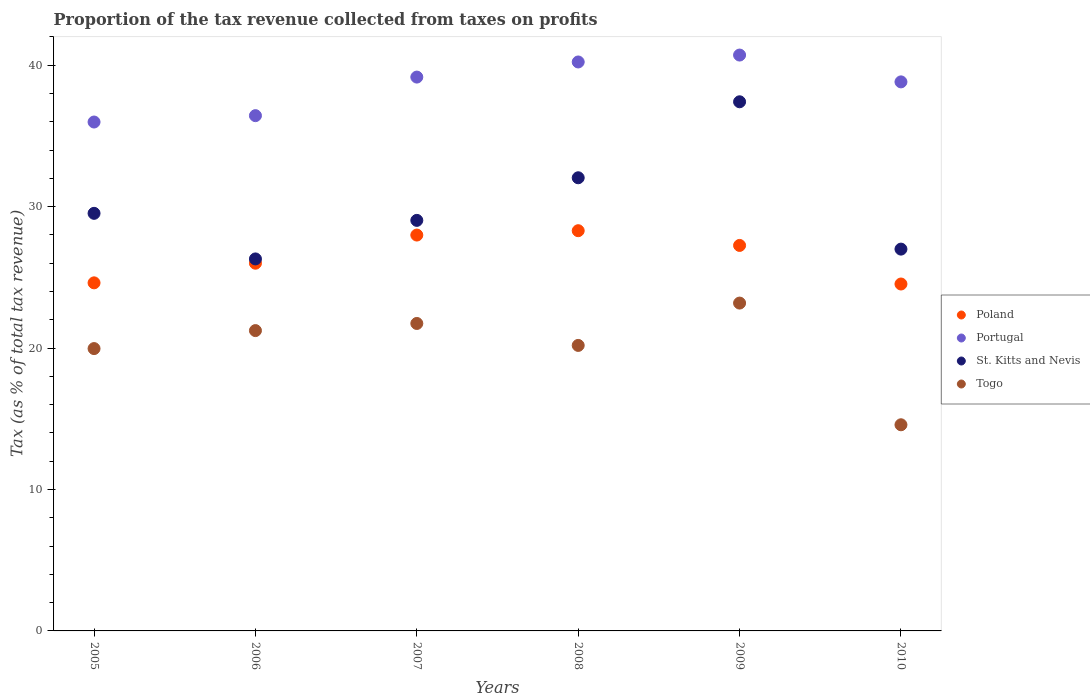What is the proportion of the tax revenue collected in Poland in 2007?
Your answer should be very brief. 27.99. Across all years, what is the maximum proportion of the tax revenue collected in Togo?
Offer a terse response. 23.18. Across all years, what is the minimum proportion of the tax revenue collected in Poland?
Offer a very short reply. 24.53. In which year was the proportion of the tax revenue collected in St. Kitts and Nevis minimum?
Provide a succinct answer. 2006. What is the total proportion of the tax revenue collected in Togo in the graph?
Offer a terse response. 120.88. What is the difference between the proportion of the tax revenue collected in St. Kitts and Nevis in 2005 and that in 2009?
Your answer should be compact. -7.89. What is the difference between the proportion of the tax revenue collected in Portugal in 2009 and the proportion of the tax revenue collected in Poland in 2008?
Your answer should be very brief. 12.42. What is the average proportion of the tax revenue collected in St. Kitts and Nevis per year?
Provide a succinct answer. 30.22. In the year 2009, what is the difference between the proportion of the tax revenue collected in Portugal and proportion of the tax revenue collected in Togo?
Offer a very short reply. 17.54. What is the ratio of the proportion of the tax revenue collected in Poland in 2005 to that in 2009?
Ensure brevity in your answer.  0.9. Is the difference between the proportion of the tax revenue collected in Portugal in 2007 and 2009 greater than the difference between the proportion of the tax revenue collected in Togo in 2007 and 2009?
Your answer should be compact. No. What is the difference between the highest and the second highest proportion of the tax revenue collected in St. Kitts and Nevis?
Offer a terse response. 5.37. What is the difference between the highest and the lowest proportion of the tax revenue collected in Portugal?
Your answer should be compact. 4.73. Is it the case that in every year, the sum of the proportion of the tax revenue collected in Poland and proportion of the tax revenue collected in St. Kitts and Nevis  is greater than the proportion of the tax revenue collected in Portugal?
Your answer should be compact. Yes. Does the proportion of the tax revenue collected in Poland monotonically increase over the years?
Give a very brief answer. No. How many dotlines are there?
Offer a very short reply. 4. How many years are there in the graph?
Your answer should be compact. 6. Are the values on the major ticks of Y-axis written in scientific E-notation?
Your response must be concise. No. Does the graph contain any zero values?
Keep it short and to the point. No. What is the title of the graph?
Offer a very short reply. Proportion of the tax revenue collected from taxes on profits. Does "Congo (Democratic)" appear as one of the legend labels in the graph?
Give a very brief answer. No. What is the label or title of the Y-axis?
Ensure brevity in your answer.  Tax (as % of total tax revenue). What is the Tax (as % of total tax revenue) in Poland in 2005?
Make the answer very short. 24.61. What is the Tax (as % of total tax revenue) in Portugal in 2005?
Your answer should be very brief. 35.98. What is the Tax (as % of total tax revenue) of St. Kitts and Nevis in 2005?
Your answer should be compact. 29.53. What is the Tax (as % of total tax revenue) of Togo in 2005?
Make the answer very short. 19.96. What is the Tax (as % of total tax revenue) of Poland in 2006?
Give a very brief answer. 26. What is the Tax (as % of total tax revenue) of Portugal in 2006?
Keep it short and to the point. 36.43. What is the Tax (as % of total tax revenue) in St. Kitts and Nevis in 2006?
Your answer should be very brief. 26.3. What is the Tax (as % of total tax revenue) of Togo in 2006?
Your answer should be compact. 21.24. What is the Tax (as % of total tax revenue) in Poland in 2007?
Your answer should be compact. 27.99. What is the Tax (as % of total tax revenue) in Portugal in 2007?
Give a very brief answer. 39.16. What is the Tax (as % of total tax revenue) of St. Kitts and Nevis in 2007?
Make the answer very short. 29.03. What is the Tax (as % of total tax revenue) of Togo in 2007?
Keep it short and to the point. 21.74. What is the Tax (as % of total tax revenue) in Poland in 2008?
Your answer should be compact. 28.3. What is the Tax (as % of total tax revenue) in Portugal in 2008?
Your answer should be very brief. 40.23. What is the Tax (as % of total tax revenue) in St. Kitts and Nevis in 2008?
Ensure brevity in your answer.  32.04. What is the Tax (as % of total tax revenue) of Togo in 2008?
Ensure brevity in your answer.  20.19. What is the Tax (as % of total tax revenue) of Poland in 2009?
Your response must be concise. 27.26. What is the Tax (as % of total tax revenue) of Portugal in 2009?
Offer a very short reply. 40.72. What is the Tax (as % of total tax revenue) of St. Kitts and Nevis in 2009?
Ensure brevity in your answer.  37.41. What is the Tax (as % of total tax revenue) in Togo in 2009?
Offer a terse response. 23.18. What is the Tax (as % of total tax revenue) of Poland in 2010?
Offer a terse response. 24.53. What is the Tax (as % of total tax revenue) in Portugal in 2010?
Give a very brief answer. 38.82. What is the Tax (as % of total tax revenue) in St. Kitts and Nevis in 2010?
Your answer should be compact. 27. What is the Tax (as % of total tax revenue) of Togo in 2010?
Provide a short and direct response. 14.58. Across all years, what is the maximum Tax (as % of total tax revenue) in Poland?
Offer a terse response. 28.3. Across all years, what is the maximum Tax (as % of total tax revenue) in Portugal?
Keep it short and to the point. 40.72. Across all years, what is the maximum Tax (as % of total tax revenue) in St. Kitts and Nevis?
Your response must be concise. 37.41. Across all years, what is the maximum Tax (as % of total tax revenue) of Togo?
Your response must be concise. 23.18. Across all years, what is the minimum Tax (as % of total tax revenue) of Poland?
Your response must be concise. 24.53. Across all years, what is the minimum Tax (as % of total tax revenue) in Portugal?
Ensure brevity in your answer.  35.98. Across all years, what is the minimum Tax (as % of total tax revenue) in St. Kitts and Nevis?
Give a very brief answer. 26.3. Across all years, what is the minimum Tax (as % of total tax revenue) of Togo?
Your answer should be very brief. 14.58. What is the total Tax (as % of total tax revenue) in Poland in the graph?
Give a very brief answer. 158.69. What is the total Tax (as % of total tax revenue) of Portugal in the graph?
Your response must be concise. 231.35. What is the total Tax (as % of total tax revenue) in St. Kitts and Nevis in the graph?
Ensure brevity in your answer.  181.31. What is the total Tax (as % of total tax revenue) of Togo in the graph?
Provide a succinct answer. 120.88. What is the difference between the Tax (as % of total tax revenue) of Poland in 2005 and that in 2006?
Ensure brevity in your answer.  -1.39. What is the difference between the Tax (as % of total tax revenue) in Portugal in 2005 and that in 2006?
Provide a short and direct response. -0.45. What is the difference between the Tax (as % of total tax revenue) in St. Kitts and Nevis in 2005 and that in 2006?
Ensure brevity in your answer.  3.22. What is the difference between the Tax (as % of total tax revenue) in Togo in 2005 and that in 2006?
Provide a succinct answer. -1.27. What is the difference between the Tax (as % of total tax revenue) in Poland in 2005 and that in 2007?
Offer a terse response. -3.38. What is the difference between the Tax (as % of total tax revenue) of Portugal in 2005 and that in 2007?
Your response must be concise. -3.18. What is the difference between the Tax (as % of total tax revenue) of St. Kitts and Nevis in 2005 and that in 2007?
Ensure brevity in your answer.  0.5. What is the difference between the Tax (as % of total tax revenue) in Togo in 2005 and that in 2007?
Your answer should be compact. -1.78. What is the difference between the Tax (as % of total tax revenue) in Poland in 2005 and that in 2008?
Your answer should be compact. -3.69. What is the difference between the Tax (as % of total tax revenue) of Portugal in 2005 and that in 2008?
Make the answer very short. -4.25. What is the difference between the Tax (as % of total tax revenue) in St. Kitts and Nevis in 2005 and that in 2008?
Offer a terse response. -2.52. What is the difference between the Tax (as % of total tax revenue) in Togo in 2005 and that in 2008?
Ensure brevity in your answer.  -0.22. What is the difference between the Tax (as % of total tax revenue) in Poland in 2005 and that in 2009?
Keep it short and to the point. -2.65. What is the difference between the Tax (as % of total tax revenue) of Portugal in 2005 and that in 2009?
Your response must be concise. -4.73. What is the difference between the Tax (as % of total tax revenue) in St. Kitts and Nevis in 2005 and that in 2009?
Provide a short and direct response. -7.89. What is the difference between the Tax (as % of total tax revenue) of Togo in 2005 and that in 2009?
Offer a terse response. -3.22. What is the difference between the Tax (as % of total tax revenue) in Poland in 2005 and that in 2010?
Make the answer very short. 0.08. What is the difference between the Tax (as % of total tax revenue) in Portugal in 2005 and that in 2010?
Give a very brief answer. -2.84. What is the difference between the Tax (as % of total tax revenue) of St. Kitts and Nevis in 2005 and that in 2010?
Your answer should be compact. 2.53. What is the difference between the Tax (as % of total tax revenue) of Togo in 2005 and that in 2010?
Ensure brevity in your answer.  5.39. What is the difference between the Tax (as % of total tax revenue) in Poland in 2006 and that in 2007?
Your answer should be compact. -1.99. What is the difference between the Tax (as % of total tax revenue) in Portugal in 2006 and that in 2007?
Provide a succinct answer. -2.73. What is the difference between the Tax (as % of total tax revenue) in St. Kitts and Nevis in 2006 and that in 2007?
Make the answer very short. -2.73. What is the difference between the Tax (as % of total tax revenue) in Togo in 2006 and that in 2007?
Your answer should be very brief. -0.5. What is the difference between the Tax (as % of total tax revenue) of Poland in 2006 and that in 2008?
Your answer should be very brief. -2.3. What is the difference between the Tax (as % of total tax revenue) of Portugal in 2006 and that in 2008?
Offer a terse response. -3.8. What is the difference between the Tax (as % of total tax revenue) in St. Kitts and Nevis in 2006 and that in 2008?
Provide a short and direct response. -5.74. What is the difference between the Tax (as % of total tax revenue) in Togo in 2006 and that in 2008?
Ensure brevity in your answer.  1.05. What is the difference between the Tax (as % of total tax revenue) of Poland in 2006 and that in 2009?
Your response must be concise. -1.26. What is the difference between the Tax (as % of total tax revenue) of Portugal in 2006 and that in 2009?
Offer a terse response. -4.28. What is the difference between the Tax (as % of total tax revenue) in St. Kitts and Nevis in 2006 and that in 2009?
Keep it short and to the point. -11.11. What is the difference between the Tax (as % of total tax revenue) of Togo in 2006 and that in 2009?
Offer a terse response. -1.95. What is the difference between the Tax (as % of total tax revenue) in Poland in 2006 and that in 2010?
Offer a terse response. 1.47. What is the difference between the Tax (as % of total tax revenue) of Portugal in 2006 and that in 2010?
Provide a short and direct response. -2.39. What is the difference between the Tax (as % of total tax revenue) in St. Kitts and Nevis in 2006 and that in 2010?
Provide a short and direct response. -0.69. What is the difference between the Tax (as % of total tax revenue) of Togo in 2006 and that in 2010?
Offer a terse response. 6.66. What is the difference between the Tax (as % of total tax revenue) of Poland in 2007 and that in 2008?
Your answer should be compact. -0.31. What is the difference between the Tax (as % of total tax revenue) of Portugal in 2007 and that in 2008?
Ensure brevity in your answer.  -1.07. What is the difference between the Tax (as % of total tax revenue) in St. Kitts and Nevis in 2007 and that in 2008?
Give a very brief answer. -3.01. What is the difference between the Tax (as % of total tax revenue) in Togo in 2007 and that in 2008?
Keep it short and to the point. 1.55. What is the difference between the Tax (as % of total tax revenue) of Poland in 2007 and that in 2009?
Provide a short and direct response. 0.73. What is the difference between the Tax (as % of total tax revenue) in Portugal in 2007 and that in 2009?
Make the answer very short. -1.56. What is the difference between the Tax (as % of total tax revenue) of St. Kitts and Nevis in 2007 and that in 2009?
Your answer should be compact. -8.39. What is the difference between the Tax (as % of total tax revenue) in Togo in 2007 and that in 2009?
Your response must be concise. -1.44. What is the difference between the Tax (as % of total tax revenue) in Poland in 2007 and that in 2010?
Keep it short and to the point. 3.46. What is the difference between the Tax (as % of total tax revenue) in Portugal in 2007 and that in 2010?
Make the answer very short. 0.34. What is the difference between the Tax (as % of total tax revenue) in St. Kitts and Nevis in 2007 and that in 2010?
Your answer should be very brief. 2.03. What is the difference between the Tax (as % of total tax revenue) in Togo in 2007 and that in 2010?
Give a very brief answer. 7.16. What is the difference between the Tax (as % of total tax revenue) of Poland in 2008 and that in 2009?
Your answer should be very brief. 1.04. What is the difference between the Tax (as % of total tax revenue) in Portugal in 2008 and that in 2009?
Give a very brief answer. -0.49. What is the difference between the Tax (as % of total tax revenue) in St. Kitts and Nevis in 2008 and that in 2009?
Make the answer very short. -5.37. What is the difference between the Tax (as % of total tax revenue) of Togo in 2008 and that in 2009?
Provide a short and direct response. -2.99. What is the difference between the Tax (as % of total tax revenue) of Poland in 2008 and that in 2010?
Make the answer very short. 3.77. What is the difference between the Tax (as % of total tax revenue) of Portugal in 2008 and that in 2010?
Offer a terse response. 1.41. What is the difference between the Tax (as % of total tax revenue) of St. Kitts and Nevis in 2008 and that in 2010?
Your answer should be compact. 5.04. What is the difference between the Tax (as % of total tax revenue) in Togo in 2008 and that in 2010?
Keep it short and to the point. 5.61. What is the difference between the Tax (as % of total tax revenue) of Poland in 2009 and that in 2010?
Make the answer very short. 2.73. What is the difference between the Tax (as % of total tax revenue) of Portugal in 2009 and that in 2010?
Provide a succinct answer. 1.9. What is the difference between the Tax (as % of total tax revenue) of St. Kitts and Nevis in 2009 and that in 2010?
Your answer should be compact. 10.42. What is the difference between the Tax (as % of total tax revenue) in Togo in 2009 and that in 2010?
Offer a terse response. 8.61. What is the difference between the Tax (as % of total tax revenue) of Poland in 2005 and the Tax (as % of total tax revenue) of Portugal in 2006?
Make the answer very short. -11.82. What is the difference between the Tax (as % of total tax revenue) in Poland in 2005 and the Tax (as % of total tax revenue) in St. Kitts and Nevis in 2006?
Provide a short and direct response. -1.69. What is the difference between the Tax (as % of total tax revenue) in Poland in 2005 and the Tax (as % of total tax revenue) in Togo in 2006?
Keep it short and to the point. 3.38. What is the difference between the Tax (as % of total tax revenue) of Portugal in 2005 and the Tax (as % of total tax revenue) of St. Kitts and Nevis in 2006?
Offer a very short reply. 9.68. What is the difference between the Tax (as % of total tax revenue) of Portugal in 2005 and the Tax (as % of total tax revenue) of Togo in 2006?
Your answer should be very brief. 14.75. What is the difference between the Tax (as % of total tax revenue) in St. Kitts and Nevis in 2005 and the Tax (as % of total tax revenue) in Togo in 2006?
Keep it short and to the point. 8.29. What is the difference between the Tax (as % of total tax revenue) of Poland in 2005 and the Tax (as % of total tax revenue) of Portugal in 2007?
Offer a terse response. -14.55. What is the difference between the Tax (as % of total tax revenue) in Poland in 2005 and the Tax (as % of total tax revenue) in St. Kitts and Nevis in 2007?
Offer a terse response. -4.42. What is the difference between the Tax (as % of total tax revenue) of Poland in 2005 and the Tax (as % of total tax revenue) of Togo in 2007?
Offer a terse response. 2.87. What is the difference between the Tax (as % of total tax revenue) of Portugal in 2005 and the Tax (as % of total tax revenue) of St. Kitts and Nevis in 2007?
Keep it short and to the point. 6.95. What is the difference between the Tax (as % of total tax revenue) of Portugal in 2005 and the Tax (as % of total tax revenue) of Togo in 2007?
Offer a terse response. 14.24. What is the difference between the Tax (as % of total tax revenue) in St. Kitts and Nevis in 2005 and the Tax (as % of total tax revenue) in Togo in 2007?
Offer a very short reply. 7.79. What is the difference between the Tax (as % of total tax revenue) in Poland in 2005 and the Tax (as % of total tax revenue) in Portugal in 2008?
Keep it short and to the point. -15.62. What is the difference between the Tax (as % of total tax revenue) in Poland in 2005 and the Tax (as % of total tax revenue) in St. Kitts and Nevis in 2008?
Your answer should be compact. -7.43. What is the difference between the Tax (as % of total tax revenue) of Poland in 2005 and the Tax (as % of total tax revenue) of Togo in 2008?
Offer a terse response. 4.42. What is the difference between the Tax (as % of total tax revenue) of Portugal in 2005 and the Tax (as % of total tax revenue) of St. Kitts and Nevis in 2008?
Your response must be concise. 3.94. What is the difference between the Tax (as % of total tax revenue) of Portugal in 2005 and the Tax (as % of total tax revenue) of Togo in 2008?
Your answer should be compact. 15.8. What is the difference between the Tax (as % of total tax revenue) of St. Kitts and Nevis in 2005 and the Tax (as % of total tax revenue) of Togo in 2008?
Offer a terse response. 9.34. What is the difference between the Tax (as % of total tax revenue) in Poland in 2005 and the Tax (as % of total tax revenue) in Portugal in 2009?
Provide a short and direct response. -16.11. What is the difference between the Tax (as % of total tax revenue) of Poland in 2005 and the Tax (as % of total tax revenue) of St. Kitts and Nevis in 2009?
Provide a short and direct response. -12.8. What is the difference between the Tax (as % of total tax revenue) of Poland in 2005 and the Tax (as % of total tax revenue) of Togo in 2009?
Make the answer very short. 1.43. What is the difference between the Tax (as % of total tax revenue) of Portugal in 2005 and the Tax (as % of total tax revenue) of St. Kitts and Nevis in 2009?
Make the answer very short. -1.43. What is the difference between the Tax (as % of total tax revenue) of Portugal in 2005 and the Tax (as % of total tax revenue) of Togo in 2009?
Keep it short and to the point. 12.8. What is the difference between the Tax (as % of total tax revenue) in St. Kitts and Nevis in 2005 and the Tax (as % of total tax revenue) in Togo in 2009?
Provide a succinct answer. 6.35. What is the difference between the Tax (as % of total tax revenue) in Poland in 2005 and the Tax (as % of total tax revenue) in Portugal in 2010?
Your response must be concise. -14.21. What is the difference between the Tax (as % of total tax revenue) in Poland in 2005 and the Tax (as % of total tax revenue) in St. Kitts and Nevis in 2010?
Keep it short and to the point. -2.39. What is the difference between the Tax (as % of total tax revenue) of Poland in 2005 and the Tax (as % of total tax revenue) of Togo in 2010?
Keep it short and to the point. 10.04. What is the difference between the Tax (as % of total tax revenue) of Portugal in 2005 and the Tax (as % of total tax revenue) of St. Kitts and Nevis in 2010?
Provide a succinct answer. 8.99. What is the difference between the Tax (as % of total tax revenue) in Portugal in 2005 and the Tax (as % of total tax revenue) in Togo in 2010?
Provide a short and direct response. 21.41. What is the difference between the Tax (as % of total tax revenue) of St. Kitts and Nevis in 2005 and the Tax (as % of total tax revenue) of Togo in 2010?
Offer a terse response. 14.95. What is the difference between the Tax (as % of total tax revenue) in Poland in 2006 and the Tax (as % of total tax revenue) in Portugal in 2007?
Your answer should be compact. -13.16. What is the difference between the Tax (as % of total tax revenue) in Poland in 2006 and the Tax (as % of total tax revenue) in St. Kitts and Nevis in 2007?
Your answer should be very brief. -3.03. What is the difference between the Tax (as % of total tax revenue) in Poland in 2006 and the Tax (as % of total tax revenue) in Togo in 2007?
Your response must be concise. 4.26. What is the difference between the Tax (as % of total tax revenue) of Portugal in 2006 and the Tax (as % of total tax revenue) of St. Kitts and Nevis in 2007?
Provide a short and direct response. 7.4. What is the difference between the Tax (as % of total tax revenue) in Portugal in 2006 and the Tax (as % of total tax revenue) in Togo in 2007?
Offer a terse response. 14.69. What is the difference between the Tax (as % of total tax revenue) in St. Kitts and Nevis in 2006 and the Tax (as % of total tax revenue) in Togo in 2007?
Ensure brevity in your answer.  4.56. What is the difference between the Tax (as % of total tax revenue) of Poland in 2006 and the Tax (as % of total tax revenue) of Portugal in 2008?
Offer a very short reply. -14.23. What is the difference between the Tax (as % of total tax revenue) in Poland in 2006 and the Tax (as % of total tax revenue) in St. Kitts and Nevis in 2008?
Ensure brevity in your answer.  -6.04. What is the difference between the Tax (as % of total tax revenue) in Poland in 2006 and the Tax (as % of total tax revenue) in Togo in 2008?
Offer a terse response. 5.81. What is the difference between the Tax (as % of total tax revenue) in Portugal in 2006 and the Tax (as % of total tax revenue) in St. Kitts and Nevis in 2008?
Keep it short and to the point. 4.39. What is the difference between the Tax (as % of total tax revenue) of Portugal in 2006 and the Tax (as % of total tax revenue) of Togo in 2008?
Your answer should be compact. 16.25. What is the difference between the Tax (as % of total tax revenue) of St. Kitts and Nevis in 2006 and the Tax (as % of total tax revenue) of Togo in 2008?
Offer a terse response. 6.12. What is the difference between the Tax (as % of total tax revenue) of Poland in 2006 and the Tax (as % of total tax revenue) of Portugal in 2009?
Offer a terse response. -14.72. What is the difference between the Tax (as % of total tax revenue) in Poland in 2006 and the Tax (as % of total tax revenue) in St. Kitts and Nevis in 2009?
Provide a short and direct response. -11.41. What is the difference between the Tax (as % of total tax revenue) of Poland in 2006 and the Tax (as % of total tax revenue) of Togo in 2009?
Make the answer very short. 2.82. What is the difference between the Tax (as % of total tax revenue) in Portugal in 2006 and the Tax (as % of total tax revenue) in St. Kitts and Nevis in 2009?
Give a very brief answer. -0.98. What is the difference between the Tax (as % of total tax revenue) of Portugal in 2006 and the Tax (as % of total tax revenue) of Togo in 2009?
Give a very brief answer. 13.25. What is the difference between the Tax (as % of total tax revenue) of St. Kitts and Nevis in 2006 and the Tax (as % of total tax revenue) of Togo in 2009?
Provide a short and direct response. 3.12. What is the difference between the Tax (as % of total tax revenue) in Poland in 2006 and the Tax (as % of total tax revenue) in Portugal in 2010?
Provide a short and direct response. -12.82. What is the difference between the Tax (as % of total tax revenue) in Poland in 2006 and the Tax (as % of total tax revenue) in St. Kitts and Nevis in 2010?
Make the answer very short. -1. What is the difference between the Tax (as % of total tax revenue) in Poland in 2006 and the Tax (as % of total tax revenue) in Togo in 2010?
Ensure brevity in your answer.  11.42. What is the difference between the Tax (as % of total tax revenue) in Portugal in 2006 and the Tax (as % of total tax revenue) in St. Kitts and Nevis in 2010?
Your response must be concise. 9.44. What is the difference between the Tax (as % of total tax revenue) of Portugal in 2006 and the Tax (as % of total tax revenue) of Togo in 2010?
Keep it short and to the point. 21.86. What is the difference between the Tax (as % of total tax revenue) of St. Kitts and Nevis in 2006 and the Tax (as % of total tax revenue) of Togo in 2010?
Make the answer very short. 11.73. What is the difference between the Tax (as % of total tax revenue) of Poland in 2007 and the Tax (as % of total tax revenue) of Portugal in 2008?
Provide a succinct answer. -12.24. What is the difference between the Tax (as % of total tax revenue) in Poland in 2007 and the Tax (as % of total tax revenue) in St. Kitts and Nevis in 2008?
Offer a terse response. -4.05. What is the difference between the Tax (as % of total tax revenue) in Poland in 2007 and the Tax (as % of total tax revenue) in Togo in 2008?
Your response must be concise. 7.8. What is the difference between the Tax (as % of total tax revenue) of Portugal in 2007 and the Tax (as % of total tax revenue) of St. Kitts and Nevis in 2008?
Your response must be concise. 7.12. What is the difference between the Tax (as % of total tax revenue) of Portugal in 2007 and the Tax (as % of total tax revenue) of Togo in 2008?
Make the answer very short. 18.97. What is the difference between the Tax (as % of total tax revenue) in St. Kitts and Nevis in 2007 and the Tax (as % of total tax revenue) in Togo in 2008?
Provide a short and direct response. 8.84. What is the difference between the Tax (as % of total tax revenue) of Poland in 2007 and the Tax (as % of total tax revenue) of Portugal in 2009?
Provide a short and direct response. -12.73. What is the difference between the Tax (as % of total tax revenue) in Poland in 2007 and the Tax (as % of total tax revenue) in St. Kitts and Nevis in 2009?
Keep it short and to the point. -9.42. What is the difference between the Tax (as % of total tax revenue) in Poland in 2007 and the Tax (as % of total tax revenue) in Togo in 2009?
Your answer should be compact. 4.81. What is the difference between the Tax (as % of total tax revenue) of Portugal in 2007 and the Tax (as % of total tax revenue) of St. Kitts and Nevis in 2009?
Keep it short and to the point. 1.75. What is the difference between the Tax (as % of total tax revenue) of Portugal in 2007 and the Tax (as % of total tax revenue) of Togo in 2009?
Provide a succinct answer. 15.98. What is the difference between the Tax (as % of total tax revenue) in St. Kitts and Nevis in 2007 and the Tax (as % of total tax revenue) in Togo in 2009?
Your answer should be compact. 5.85. What is the difference between the Tax (as % of total tax revenue) in Poland in 2007 and the Tax (as % of total tax revenue) in Portugal in 2010?
Provide a succinct answer. -10.83. What is the difference between the Tax (as % of total tax revenue) in Poland in 2007 and the Tax (as % of total tax revenue) in Togo in 2010?
Make the answer very short. 13.41. What is the difference between the Tax (as % of total tax revenue) of Portugal in 2007 and the Tax (as % of total tax revenue) of St. Kitts and Nevis in 2010?
Provide a short and direct response. 12.16. What is the difference between the Tax (as % of total tax revenue) of Portugal in 2007 and the Tax (as % of total tax revenue) of Togo in 2010?
Give a very brief answer. 24.59. What is the difference between the Tax (as % of total tax revenue) of St. Kitts and Nevis in 2007 and the Tax (as % of total tax revenue) of Togo in 2010?
Offer a very short reply. 14.45. What is the difference between the Tax (as % of total tax revenue) of Poland in 2008 and the Tax (as % of total tax revenue) of Portugal in 2009?
Provide a short and direct response. -12.42. What is the difference between the Tax (as % of total tax revenue) of Poland in 2008 and the Tax (as % of total tax revenue) of St. Kitts and Nevis in 2009?
Offer a very short reply. -9.12. What is the difference between the Tax (as % of total tax revenue) of Poland in 2008 and the Tax (as % of total tax revenue) of Togo in 2009?
Your response must be concise. 5.12. What is the difference between the Tax (as % of total tax revenue) in Portugal in 2008 and the Tax (as % of total tax revenue) in St. Kitts and Nevis in 2009?
Your response must be concise. 2.82. What is the difference between the Tax (as % of total tax revenue) in Portugal in 2008 and the Tax (as % of total tax revenue) in Togo in 2009?
Provide a succinct answer. 17.05. What is the difference between the Tax (as % of total tax revenue) in St. Kitts and Nevis in 2008 and the Tax (as % of total tax revenue) in Togo in 2009?
Your answer should be compact. 8.86. What is the difference between the Tax (as % of total tax revenue) in Poland in 2008 and the Tax (as % of total tax revenue) in Portugal in 2010?
Make the answer very short. -10.52. What is the difference between the Tax (as % of total tax revenue) in Poland in 2008 and the Tax (as % of total tax revenue) in St. Kitts and Nevis in 2010?
Provide a short and direct response. 1.3. What is the difference between the Tax (as % of total tax revenue) of Poland in 2008 and the Tax (as % of total tax revenue) of Togo in 2010?
Provide a succinct answer. 13.72. What is the difference between the Tax (as % of total tax revenue) of Portugal in 2008 and the Tax (as % of total tax revenue) of St. Kitts and Nevis in 2010?
Ensure brevity in your answer.  13.23. What is the difference between the Tax (as % of total tax revenue) in Portugal in 2008 and the Tax (as % of total tax revenue) in Togo in 2010?
Keep it short and to the point. 25.65. What is the difference between the Tax (as % of total tax revenue) in St. Kitts and Nevis in 2008 and the Tax (as % of total tax revenue) in Togo in 2010?
Offer a very short reply. 17.47. What is the difference between the Tax (as % of total tax revenue) of Poland in 2009 and the Tax (as % of total tax revenue) of Portugal in 2010?
Provide a short and direct response. -11.56. What is the difference between the Tax (as % of total tax revenue) in Poland in 2009 and the Tax (as % of total tax revenue) in St. Kitts and Nevis in 2010?
Give a very brief answer. 0.26. What is the difference between the Tax (as % of total tax revenue) in Poland in 2009 and the Tax (as % of total tax revenue) in Togo in 2010?
Offer a terse response. 12.68. What is the difference between the Tax (as % of total tax revenue) of Portugal in 2009 and the Tax (as % of total tax revenue) of St. Kitts and Nevis in 2010?
Keep it short and to the point. 13.72. What is the difference between the Tax (as % of total tax revenue) of Portugal in 2009 and the Tax (as % of total tax revenue) of Togo in 2010?
Offer a terse response. 26.14. What is the difference between the Tax (as % of total tax revenue) in St. Kitts and Nevis in 2009 and the Tax (as % of total tax revenue) in Togo in 2010?
Ensure brevity in your answer.  22.84. What is the average Tax (as % of total tax revenue) of Poland per year?
Make the answer very short. 26.45. What is the average Tax (as % of total tax revenue) in Portugal per year?
Your answer should be compact. 38.56. What is the average Tax (as % of total tax revenue) in St. Kitts and Nevis per year?
Offer a terse response. 30.22. What is the average Tax (as % of total tax revenue) of Togo per year?
Offer a terse response. 20.15. In the year 2005, what is the difference between the Tax (as % of total tax revenue) in Poland and Tax (as % of total tax revenue) in Portugal?
Your answer should be very brief. -11.37. In the year 2005, what is the difference between the Tax (as % of total tax revenue) in Poland and Tax (as % of total tax revenue) in St. Kitts and Nevis?
Ensure brevity in your answer.  -4.91. In the year 2005, what is the difference between the Tax (as % of total tax revenue) of Poland and Tax (as % of total tax revenue) of Togo?
Offer a terse response. 4.65. In the year 2005, what is the difference between the Tax (as % of total tax revenue) in Portugal and Tax (as % of total tax revenue) in St. Kitts and Nevis?
Make the answer very short. 6.46. In the year 2005, what is the difference between the Tax (as % of total tax revenue) in Portugal and Tax (as % of total tax revenue) in Togo?
Your answer should be very brief. 16.02. In the year 2005, what is the difference between the Tax (as % of total tax revenue) in St. Kitts and Nevis and Tax (as % of total tax revenue) in Togo?
Make the answer very short. 9.56. In the year 2006, what is the difference between the Tax (as % of total tax revenue) in Poland and Tax (as % of total tax revenue) in Portugal?
Provide a succinct answer. -10.43. In the year 2006, what is the difference between the Tax (as % of total tax revenue) in Poland and Tax (as % of total tax revenue) in St. Kitts and Nevis?
Offer a terse response. -0.3. In the year 2006, what is the difference between the Tax (as % of total tax revenue) of Poland and Tax (as % of total tax revenue) of Togo?
Provide a succinct answer. 4.76. In the year 2006, what is the difference between the Tax (as % of total tax revenue) of Portugal and Tax (as % of total tax revenue) of St. Kitts and Nevis?
Keep it short and to the point. 10.13. In the year 2006, what is the difference between the Tax (as % of total tax revenue) in Portugal and Tax (as % of total tax revenue) in Togo?
Offer a terse response. 15.2. In the year 2006, what is the difference between the Tax (as % of total tax revenue) of St. Kitts and Nevis and Tax (as % of total tax revenue) of Togo?
Ensure brevity in your answer.  5.07. In the year 2007, what is the difference between the Tax (as % of total tax revenue) in Poland and Tax (as % of total tax revenue) in Portugal?
Provide a short and direct response. -11.17. In the year 2007, what is the difference between the Tax (as % of total tax revenue) in Poland and Tax (as % of total tax revenue) in St. Kitts and Nevis?
Make the answer very short. -1.04. In the year 2007, what is the difference between the Tax (as % of total tax revenue) of Poland and Tax (as % of total tax revenue) of Togo?
Your answer should be very brief. 6.25. In the year 2007, what is the difference between the Tax (as % of total tax revenue) of Portugal and Tax (as % of total tax revenue) of St. Kitts and Nevis?
Provide a succinct answer. 10.13. In the year 2007, what is the difference between the Tax (as % of total tax revenue) in Portugal and Tax (as % of total tax revenue) in Togo?
Your answer should be compact. 17.42. In the year 2007, what is the difference between the Tax (as % of total tax revenue) in St. Kitts and Nevis and Tax (as % of total tax revenue) in Togo?
Your response must be concise. 7.29. In the year 2008, what is the difference between the Tax (as % of total tax revenue) in Poland and Tax (as % of total tax revenue) in Portugal?
Your answer should be compact. -11.93. In the year 2008, what is the difference between the Tax (as % of total tax revenue) in Poland and Tax (as % of total tax revenue) in St. Kitts and Nevis?
Offer a very short reply. -3.74. In the year 2008, what is the difference between the Tax (as % of total tax revenue) of Poland and Tax (as % of total tax revenue) of Togo?
Offer a very short reply. 8.11. In the year 2008, what is the difference between the Tax (as % of total tax revenue) of Portugal and Tax (as % of total tax revenue) of St. Kitts and Nevis?
Ensure brevity in your answer.  8.19. In the year 2008, what is the difference between the Tax (as % of total tax revenue) of Portugal and Tax (as % of total tax revenue) of Togo?
Your answer should be very brief. 20.04. In the year 2008, what is the difference between the Tax (as % of total tax revenue) in St. Kitts and Nevis and Tax (as % of total tax revenue) in Togo?
Your answer should be compact. 11.85. In the year 2009, what is the difference between the Tax (as % of total tax revenue) of Poland and Tax (as % of total tax revenue) of Portugal?
Your response must be concise. -13.46. In the year 2009, what is the difference between the Tax (as % of total tax revenue) in Poland and Tax (as % of total tax revenue) in St. Kitts and Nevis?
Keep it short and to the point. -10.16. In the year 2009, what is the difference between the Tax (as % of total tax revenue) in Poland and Tax (as % of total tax revenue) in Togo?
Provide a succinct answer. 4.08. In the year 2009, what is the difference between the Tax (as % of total tax revenue) in Portugal and Tax (as % of total tax revenue) in St. Kitts and Nevis?
Your answer should be very brief. 3.3. In the year 2009, what is the difference between the Tax (as % of total tax revenue) of Portugal and Tax (as % of total tax revenue) of Togo?
Keep it short and to the point. 17.54. In the year 2009, what is the difference between the Tax (as % of total tax revenue) of St. Kitts and Nevis and Tax (as % of total tax revenue) of Togo?
Ensure brevity in your answer.  14.23. In the year 2010, what is the difference between the Tax (as % of total tax revenue) of Poland and Tax (as % of total tax revenue) of Portugal?
Make the answer very short. -14.29. In the year 2010, what is the difference between the Tax (as % of total tax revenue) in Poland and Tax (as % of total tax revenue) in St. Kitts and Nevis?
Give a very brief answer. -2.47. In the year 2010, what is the difference between the Tax (as % of total tax revenue) of Poland and Tax (as % of total tax revenue) of Togo?
Offer a terse response. 9.95. In the year 2010, what is the difference between the Tax (as % of total tax revenue) in Portugal and Tax (as % of total tax revenue) in St. Kitts and Nevis?
Give a very brief answer. 11.82. In the year 2010, what is the difference between the Tax (as % of total tax revenue) in Portugal and Tax (as % of total tax revenue) in Togo?
Provide a short and direct response. 24.25. In the year 2010, what is the difference between the Tax (as % of total tax revenue) of St. Kitts and Nevis and Tax (as % of total tax revenue) of Togo?
Give a very brief answer. 12.42. What is the ratio of the Tax (as % of total tax revenue) in Poland in 2005 to that in 2006?
Your answer should be very brief. 0.95. What is the ratio of the Tax (as % of total tax revenue) of Portugal in 2005 to that in 2006?
Provide a short and direct response. 0.99. What is the ratio of the Tax (as % of total tax revenue) in St. Kitts and Nevis in 2005 to that in 2006?
Provide a short and direct response. 1.12. What is the ratio of the Tax (as % of total tax revenue) of Togo in 2005 to that in 2006?
Give a very brief answer. 0.94. What is the ratio of the Tax (as % of total tax revenue) of Poland in 2005 to that in 2007?
Offer a very short reply. 0.88. What is the ratio of the Tax (as % of total tax revenue) in Portugal in 2005 to that in 2007?
Give a very brief answer. 0.92. What is the ratio of the Tax (as % of total tax revenue) of St. Kitts and Nevis in 2005 to that in 2007?
Your answer should be very brief. 1.02. What is the ratio of the Tax (as % of total tax revenue) of Togo in 2005 to that in 2007?
Give a very brief answer. 0.92. What is the ratio of the Tax (as % of total tax revenue) of Poland in 2005 to that in 2008?
Make the answer very short. 0.87. What is the ratio of the Tax (as % of total tax revenue) in Portugal in 2005 to that in 2008?
Provide a succinct answer. 0.89. What is the ratio of the Tax (as % of total tax revenue) of St. Kitts and Nevis in 2005 to that in 2008?
Give a very brief answer. 0.92. What is the ratio of the Tax (as % of total tax revenue) of Togo in 2005 to that in 2008?
Ensure brevity in your answer.  0.99. What is the ratio of the Tax (as % of total tax revenue) in Poland in 2005 to that in 2009?
Your answer should be very brief. 0.9. What is the ratio of the Tax (as % of total tax revenue) in Portugal in 2005 to that in 2009?
Provide a short and direct response. 0.88. What is the ratio of the Tax (as % of total tax revenue) of St. Kitts and Nevis in 2005 to that in 2009?
Offer a very short reply. 0.79. What is the ratio of the Tax (as % of total tax revenue) of Togo in 2005 to that in 2009?
Provide a short and direct response. 0.86. What is the ratio of the Tax (as % of total tax revenue) in Portugal in 2005 to that in 2010?
Your answer should be compact. 0.93. What is the ratio of the Tax (as % of total tax revenue) in St. Kitts and Nevis in 2005 to that in 2010?
Make the answer very short. 1.09. What is the ratio of the Tax (as % of total tax revenue) in Togo in 2005 to that in 2010?
Your answer should be very brief. 1.37. What is the ratio of the Tax (as % of total tax revenue) in Poland in 2006 to that in 2007?
Your answer should be very brief. 0.93. What is the ratio of the Tax (as % of total tax revenue) in Portugal in 2006 to that in 2007?
Give a very brief answer. 0.93. What is the ratio of the Tax (as % of total tax revenue) in St. Kitts and Nevis in 2006 to that in 2007?
Ensure brevity in your answer.  0.91. What is the ratio of the Tax (as % of total tax revenue) of Togo in 2006 to that in 2007?
Your answer should be very brief. 0.98. What is the ratio of the Tax (as % of total tax revenue) in Poland in 2006 to that in 2008?
Your answer should be compact. 0.92. What is the ratio of the Tax (as % of total tax revenue) of Portugal in 2006 to that in 2008?
Provide a short and direct response. 0.91. What is the ratio of the Tax (as % of total tax revenue) of St. Kitts and Nevis in 2006 to that in 2008?
Keep it short and to the point. 0.82. What is the ratio of the Tax (as % of total tax revenue) of Togo in 2006 to that in 2008?
Your response must be concise. 1.05. What is the ratio of the Tax (as % of total tax revenue) in Poland in 2006 to that in 2009?
Your answer should be compact. 0.95. What is the ratio of the Tax (as % of total tax revenue) in Portugal in 2006 to that in 2009?
Provide a succinct answer. 0.89. What is the ratio of the Tax (as % of total tax revenue) of St. Kitts and Nevis in 2006 to that in 2009?
Give a very brief answer. 0.7. What is the ratio of the Tax (as % of total tax revenue) in Togo in 2006 to that in 2009?
Provide a short and direct response. 0.92. What is the ratio of the Tax (as % of total tax revenue) of Poland in 2006 to that in 2010?
Your response must be concise. 1.06. What is the ratio of the Tax (as % of total tax revenue) of Portugal in 2006 to that in 2010?
Offer a terse response. 0.94. What is the ratio of the Tax (as % of total tax revenue) in St. Kitts and Nevis in 2006 to that in 2010?
Provide a succinct answer. 0.97. What is the ratio of the Tax (as % of total tax revenue) of Togo in 2006 to that in 2010?
Offer a very short reply. 1.46. What is the ratio of the Tax (as % of total tax revenue) of Poland in 2007 to that in 2008?
Provide a succinct answer. 0.99. What is the ratio of the Tax (as % of total tax revenue) of Portugal in 2007 to that in 2008?
Keep it short and to the point. 0.97. What is the ratio of the Tax (as % of total tax revenue) of St. Kitts and Nevis in 2007 to that in 2008?
Your response must be concise. 0.91. What is the ratio of the Tax (as % of total tax revenue) in Togo in 2007 to that in 2008?
Your response must be concise. 1.08. What is the ratio of the Tax (as % of total tax revenue) of Poland in 2007 to that in 2009?
Provide a succinct answer. 1.03. What is the ratio of the Tax (as % of total tax revenue) in Portugal in 2007 to that in 2009?
Provide a succinct answer. 0.96. What is the ratio of the Tax (as % of total tax revenue) in St. Kitts and Nevis in 2007 to that in 2009?
Make the answer very short. 0.78. What is the ratio of the Tax (as % of total tax revenue) of Togo in 2007 to that in 2009?
Your answer should be compact. 0.94. What is the ratio of the Tax (as % of total tax revenue) of Poland in 2007 to that in 2010?
Your answer should be very brief. 1.14. What is the ratio of the Tax (as % of total tax revenue) of Portugal in 2007 to that in 2010?
Provide a succinct answer. 1.01. What is the ratio of the Tax (as % of total tax revenue) in St. Kitts and Nevis in 2007 to that in 2010?
Offer a very short reply. 1.08. What is the ratio of the Tax (as % of total tax revenue) of Togo in 2007 to that in 2010?
Provide a short and direct response. 1.49. What is the ratio of the Tax (as % of total tax revenue) of Poland in 2008 to that in 2009?
Offer a terse response. 1.04. What is the ratio of the Tax (as % of total tax revenue) of Portugal in 2008 to that in 2009?
Offer a terse response. 0.99. What is the ratio of the Tax (as % of total tax revenue) of St. Kitts and Nevis in 2008 to that in 2009?
Provide a succinct answer. 0.86. What is the ratio of the Tax (as % of total tax revenue) in Togo in 2008 to that in 2009?
Your answer should be compact. 0.87. What is the ratio of the Tax (as % of total tax revenue) in Poland in 2008 to that in 2010?
Offer a terse response. 1.15. What is the ratio of the Tax (as % of total tax revenue) in Portugal in 2008 to that in 2010?
Give a very brief answer. 1.04. What is the ratio of the Tax (as % of total tax revenue) in St. Kitts and Nevis in 2008 to that in 2010?
Your answer should be compact. 1.19. What is the ratio of the Tax (as % of total tax revenue) of Togo in 2008 to that in 2010?
Give a very brief answer. 1.38. What is the ratio of the Tax (as % of total tax revenue) of Poland in 2009 to that in 2010?
Your response must be concise. 1.11. What is the ratio of the Tax (as % of total tax revenue) in Portugal in 2009 to that in 2010?
Your answer should be compact. 1.05. What is the ratio of the Tax (as % of total tax revenue) of St. Kitts and Nevis in 2009 to that in 2010?
Offer a very short reply. 1.39. What is the ratio of the Tax (as % of total tax revenue) in Togo in 2009 to that in 2010?
Give a very brief answer. 1.59. What is the difference between the highest and the second highest Tax (as % of total tax revenue) of Poland?
Give a very brief answer. 0.31. What is the difference between the highest and the second highest Tax (as % of total tax revenue) in Portugal?
Your response must be concise. 0.49. What is the difference between the highest and the second highest Tax (as % of total tax revenue) of St. Kitts and Nevis?
Your answer should be compact. 5.37. What is the difference between the highest and the second highest Tax (as % of total tax revenue) in Togo?
Provide a succinct answer. 1.44. What is the difference between the highest and the lowest Tax (as % of total tax revenue) of Poland?
Offer a very short reply. 3.77. What is the difference between the highest and the lowest Tax (as % of total tax revenue) in Portugal?
Provide a succinct answer. 4.73. What is the difference between the highest and the lowest Tax (as % of total tax revenue) in St. Kitts and Nevis?
Your response must be concise. 11.11. What is the difference between the highest and the lowest Tax (as % of total tax revenue) of Togo?
Your answer should be compact. 8.61. 